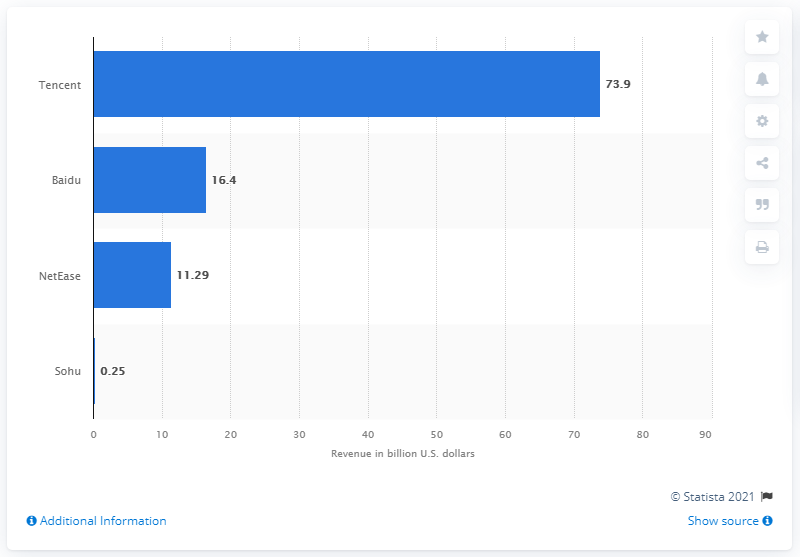Mention a couple of crucial points in this snapshot. Baidu, a leading Chinese language internet search provider, came in second with a revenue of 16.4 billion U.S. dollars. The leading Chinese internet portal is named Tencent. 